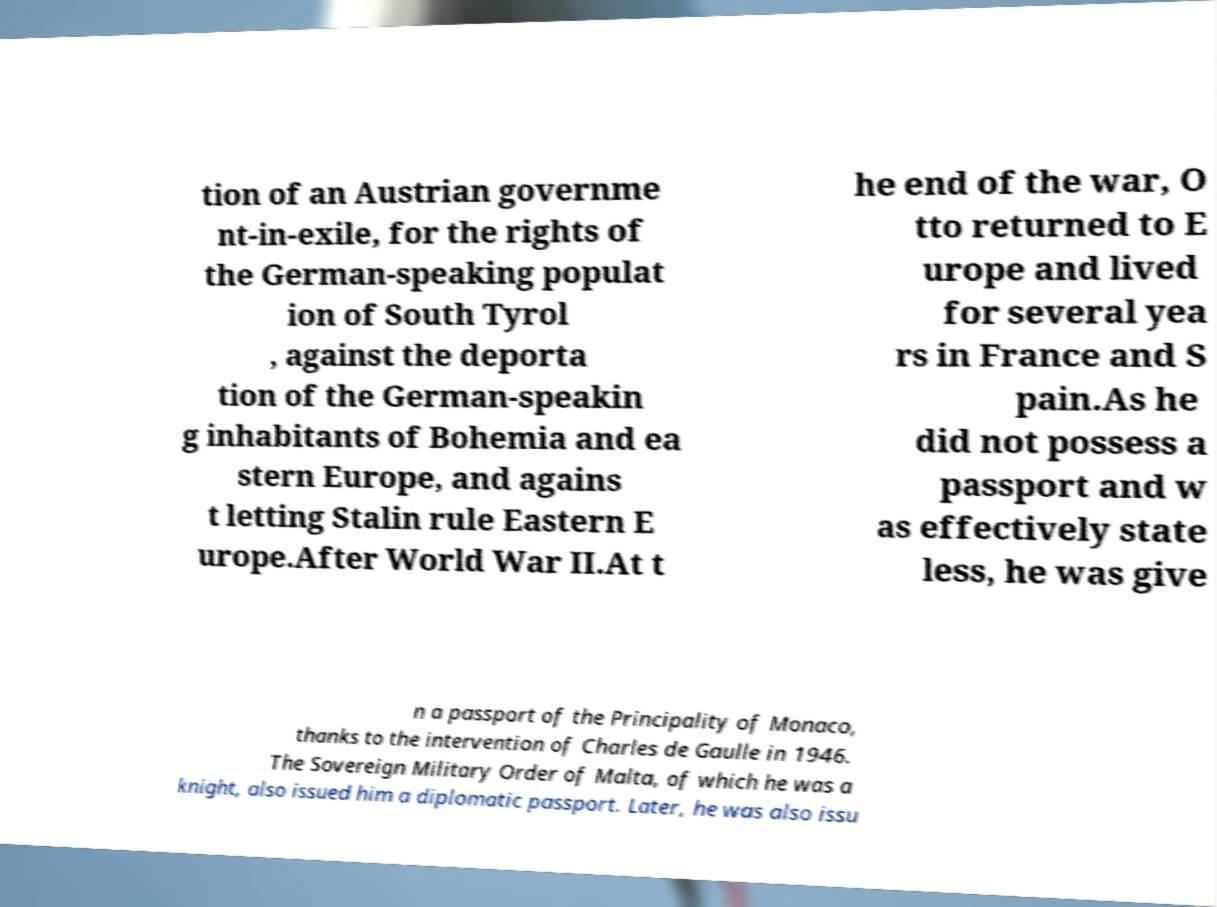Please identify and transcribe the text found in this image. tion of an Austrian governme nt-in-exile, for the rights of the German-speaking populat ion of South Tyrol , against the deporta tion of the German-speakin g inhabitants of Bohemia and ea stern Europe, and agains t letting Stalin rule Eastern E urope.After World War II.At t he end of the war, O tto returned to E urope and lived for several yea rs in France and S pain.As he did not possess a passport and w as effectively state less, he was give n a passport of the Principality of Monaco, thanks to the intervention of Charles de Gaulle in 1946. The Sovereign Military Order of Malta, of which he was a knight, also issued him a diplomatic passport. Later, he was also issu 